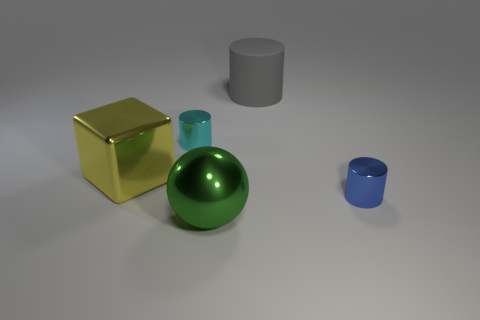Add 5 yellow metallic blocks. How many objects exist? 10 Subtract all balls. How many objects are left? 4 Subtract all big red metal cylinders. Subtract all blue metallic objects. How many objects are left? 4 Add 1 big cylinders. How many big cylinders are left? 2 Add 4 small gray cylinders. How many small gray cylinders exist? 4 Subtract 0 blue spheres. How many objects are left? 5 